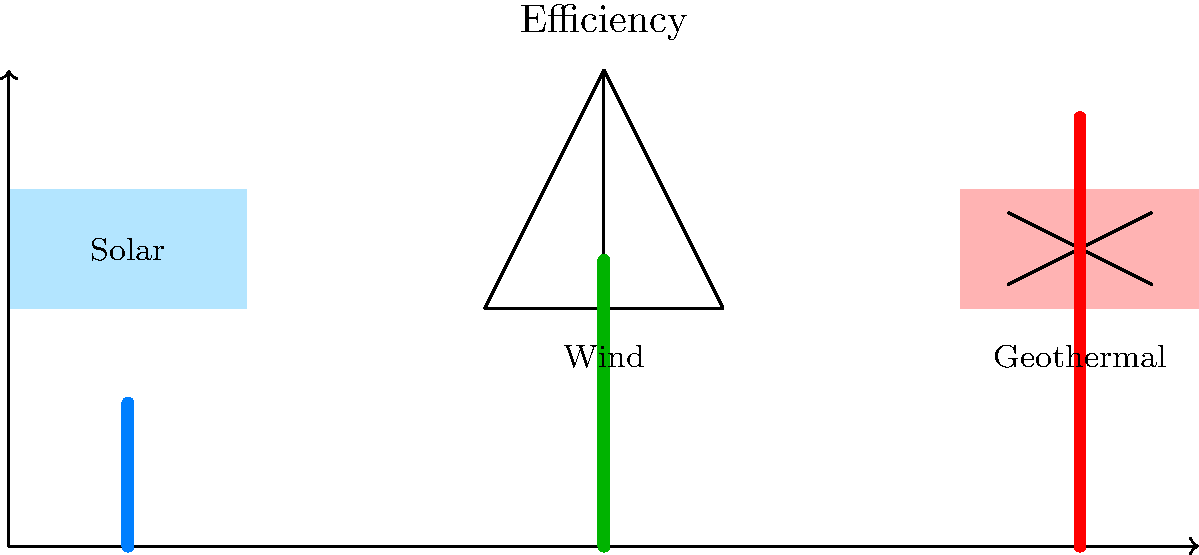Based on the schematic diagram comparing three renewable energy systems for commercial properties, which system appears to have the highest efficiency and would be most suitable for a business owner looking to maximize energy output in a limited space? To determine the most efficient and suitable renewable energy system for a business owner with limited space, let's analyze the schematic diagram:

1. The diagram shows three renewable energy systems: Solar, Wind, and Geothermal.
2. Below each system, there's an efficiency bar graph:
   - Solar (blue bar): Extends to about 40% of the scale
   - Wind (green bar): Extends to about 60% of the scale
   - Geothermal (red bar): Extends to about 80% of the scale
3. The height of each bar represents the relative efficiency of the system.
4. Geothermal has the tallest bar, indicating the highest efficiency among the three options.
5. For a business owner with limited space, efficiency is crucial to maximize energy output.
6. While all three systems are eco-friendly, geothermal appears to offer the best efficiency-to-space ratio.
7. Geothermal systems can provide consistent energy output regardless of weather conditions, unlike solar or wind.
8. The high efficiency of geothermal makes it suitable for commercial properties where space may be at a premium.

Therefore, based on the efficiency shown in the diagram and considering the need to maximize energy output in a limited space, the geothermal system appears to be the most suitable choice for the business owner.
Answer: Geothermal 